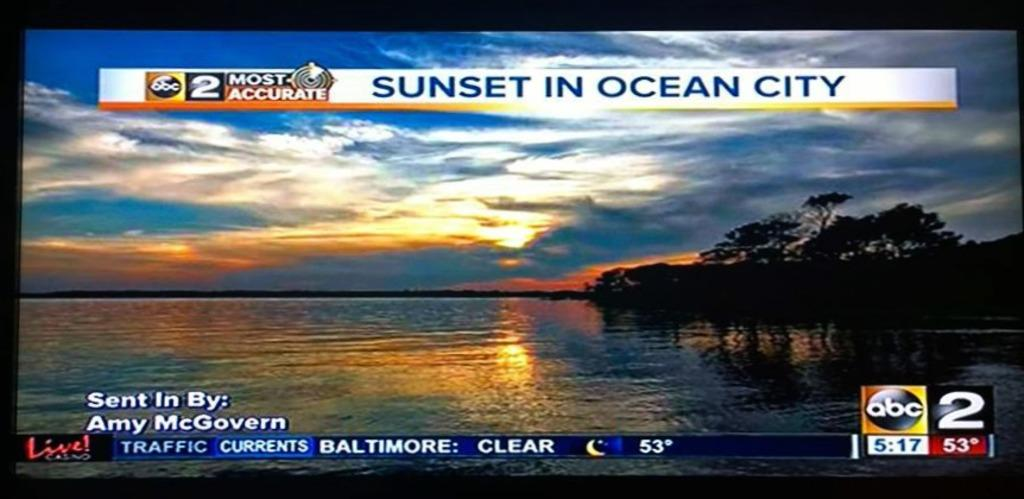<image>
Describe the image concisely. a sunset in ocean city title that has water under it 